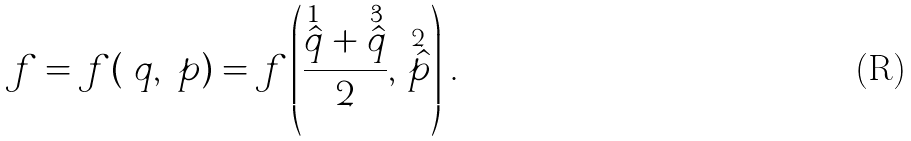Convert formula to latex. <formula><loc_0><loc_0><loc_500><loc_500>\ f = f ( \ q , \ p ) = f \left ( \frac { \stackrel { 1 } { \hat { q } } + \stackrel { 3 } { \hat { q } } } 2 , \, \stackrel { 2 } { \hat { p } } \right ) \, .</formula> 